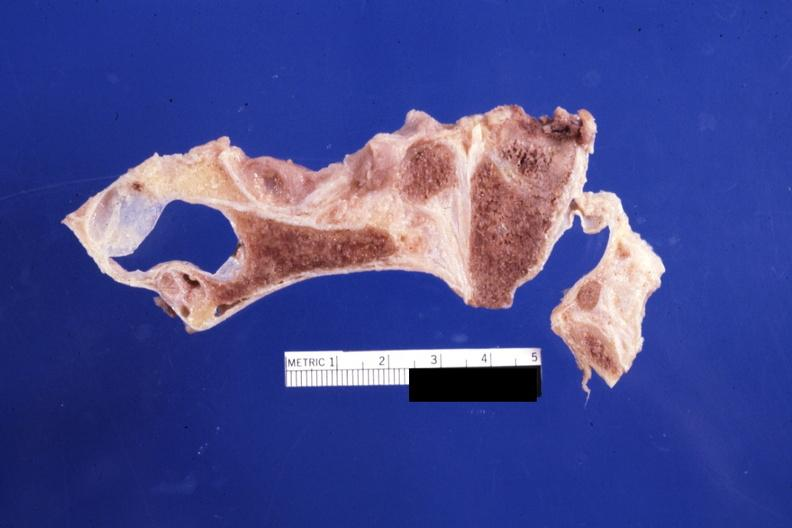what is present?
Answer the question using a single word or phrase. Rheumatoid arthritis 